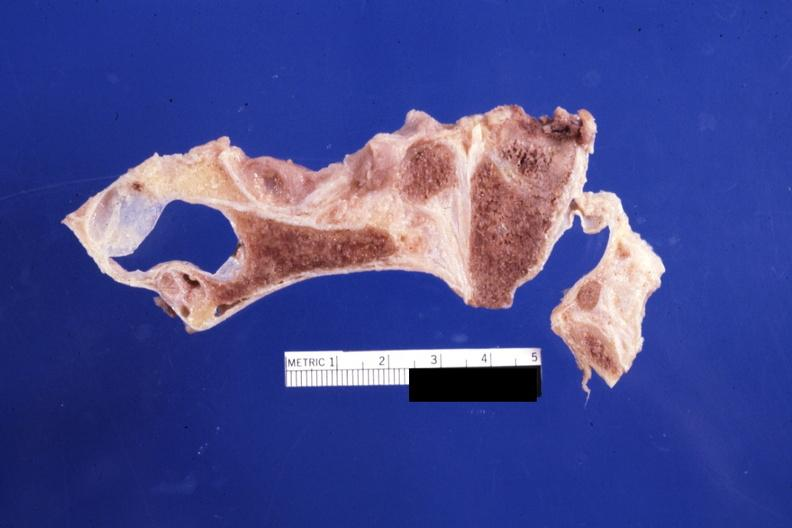what is present?
Answer the question using a single word or phrase. Rheumatoid arthritis 